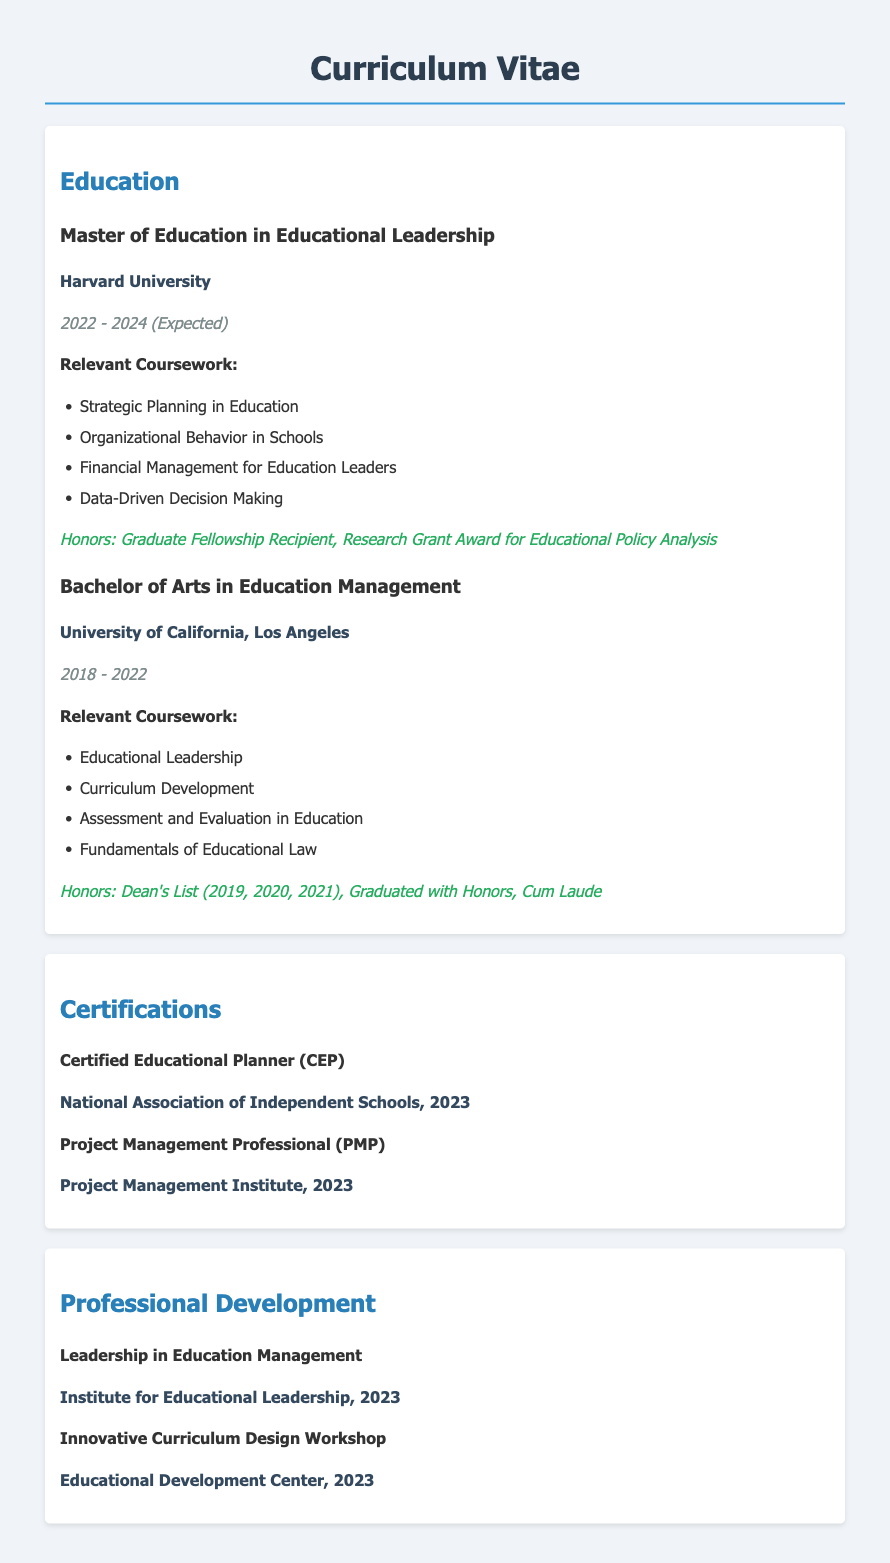What is the expected graduation year for the Master's degree? The expected graduation year for the Master's degree is stated in the document as 2024.
Answer: 2024 What institution awarded the Bachelor of Arts in Education Management? The document specifies that the Bachelor of Arts in Education Management was awarded by the University of California, Los Angeles.
Answer: University of California, Los Angeles Which honors were received during the Bachelor's program? The document lists the honors received during the Bachelor's program as Dean's List (2019, 2020, 2021), Graduated with Honors, Cum Laude.
Answer: Dean's List (2019, 2020, 2021), Graduated with Honors, Cum Laude How many relevant courses are listed for the Master’s degree? The relevant courses for the Master’s degree are specifically enumerated in the document; there are four courses listed.
Answer: Four What are the two certifications obtained in 2023? The document mentions two certifications obtained in 2023: Certified Educational Planner (CEP) and Project Management Professional (PMP).
Answer: Certified Educational Planner (CEP), Project Management Professional (PMP) Who organized the "Leadership in Education Management" professional development? The document states that the "Leadership in Education Management" professional development was organized by the Institute for Educational Leadership.
Answer: Institute for Educational Leadership What is the total number of educational achievements listed in the document? The document includes a total of four educational achievements, two degrees and two certifications.
Answer: Four What is the main focus of the relevant coursework for the Master’s degree? The relevant coursework for the Master’s degree focuses on educational leadership and management concepts.
Answer: Educational leadership and management concepts 